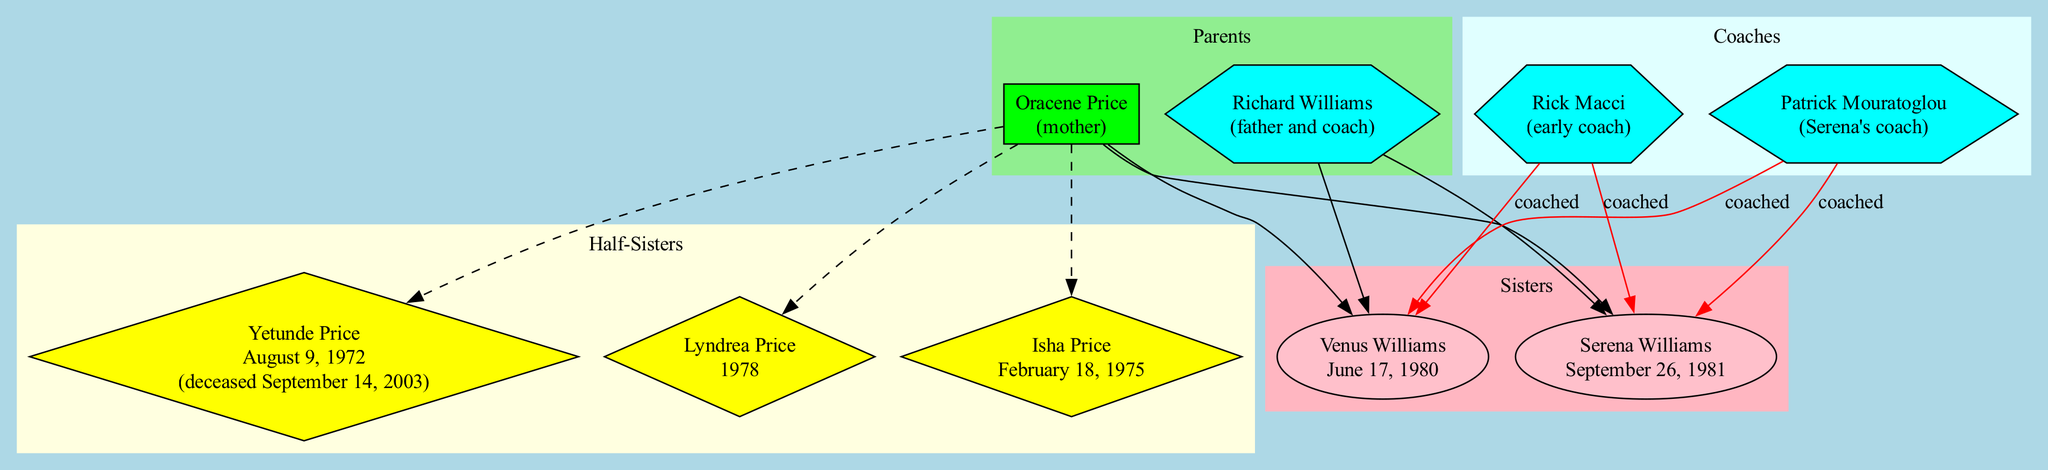What are the names of the two sisters? The diagram lists "Venus Williams" and "Serena Williams" as the sisters. These names are displayed in the section labeled 'Sisters.'
Answer: Venus Williams, Serena Williams How many half-sisters do the Williams sisters have? The diagram shows three half-sisters under the 'Half-Sisters' subgraph: Yetunde Price, Lyndrea Price, and Isha Price. Counting them gives a total of three.
Answer: 3 Who coached both Venus and Serena? Richard Williams is identified as both their father and coach in the 'Coaches' section, indicating that he played a significant role in training them.
Answer: Richard Williams Which coach is associated specifically with Serena? The diagram labels Patrick Mouratoglou as "Serena's coach." This clearly indicates his dedicated role in Serena's training.
Answer: Patrick Mouratoglou Which half-sister is listed as deceased? The diagram presents Yetunde Price with a note indicating her date of death: "deceased September 14, 2003," making it clear that she is the only half-sister mentioned as deceased.
Answer: Yetunde Price What is the relationship between Venus Williams and Isha Price? Based on the diagram, Venus Williams is a full sister, while Isha Price is a half-sister. Their relationship is differentiated in the diagram as such.
Answer: Half-sister How many coaches are listed in the diagram? The diagram identifies three coaches including Richard Williams, Rick Macci, and Patrick Mouratoglou. Thus, the total number of coaches listed is three.
Answer: 3 What shape represents the sisters in the diagram? In the subgraph labeled 'Sisters,' the nodes representing the sisters are displayed in the shape of ellipses, which is characteristic of that section.
Answer: Ellipses What color is used for the parents' section? The 'Parents' subgraph is marked with a light green color according to the diagram's attributes indicating different sections visually.
Answer: Light green 